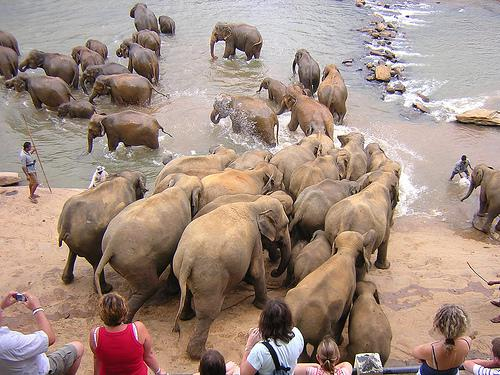Question: what animal is shown?
Choices:
A. Elephant.
B. Giraffe.
C. Whale.
D. Bird.
Answer with the letter. Answer: A Question: what are the animals walking in?
Choices:
A. A dirt road.
B. A paved road.
C. The lake.
D. River.
Answer with the letter. Answer: D Question: where is this shot?
Choices:
A. The beach.
B. River bank.
C. A mountain.
D. A ski slope.
Answer with the letter. Answer: B Question: how many types of animals are in the shot?
Choices:
A. 2.
B. 1.
C. 3.
D. 0.
Answer with the letter. Answer: B Question: what color are the elephants?
Choices:
A. Grey.
B. Brown.
C. Black.
D. White.
Answer with the letter. Answer: A 